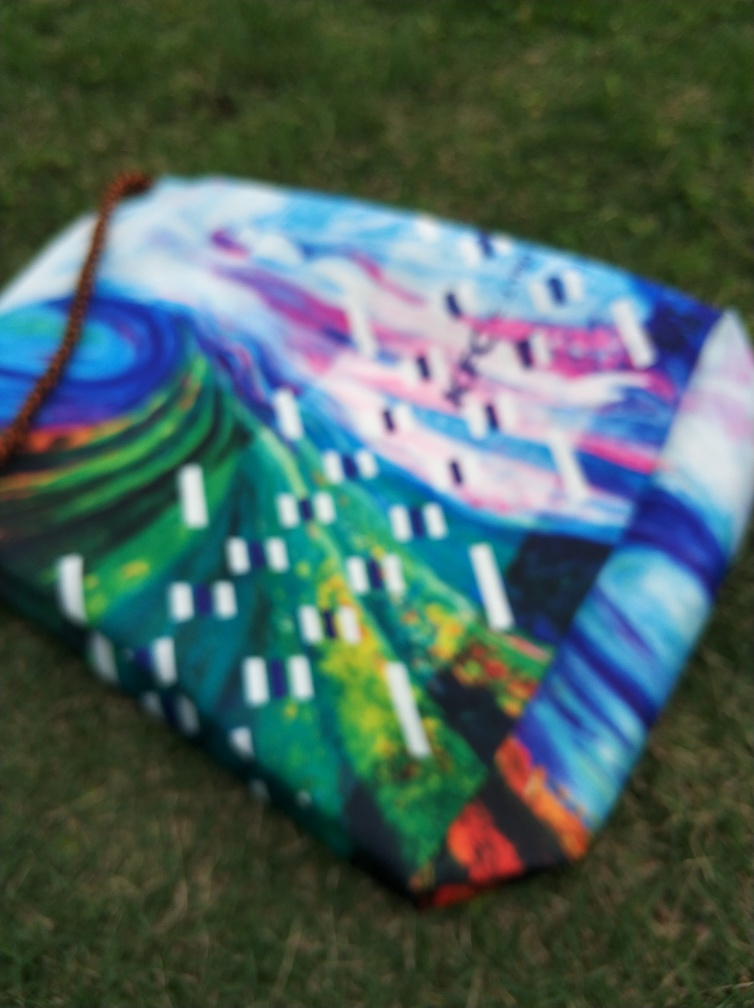What is the quality of this picture? The quality of the picture is quite low due to the prominent blur, which obscures the details of what appears to be a colorful, abstract painting. It could be improved with a clearer focus to showcase the artwork's details. 